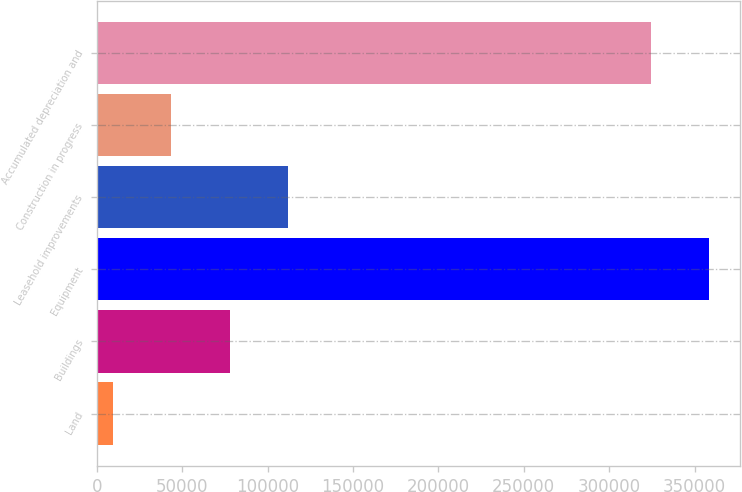Convert chart to OTSL. <chart><loc_0><loc_0><loc_500><loc_500><bar_chart><fcel>Land<fcel>Buildings<fcel>Equipment<fcel>Leasehold improvements<fcel>Construction in progress<fcel>Accumulated depreciation and<nl><fcel>9581<fcel>77899.4<fcel>358431<fcel>112059<fcel>43740.2<fcel>324272<nl></chart> 